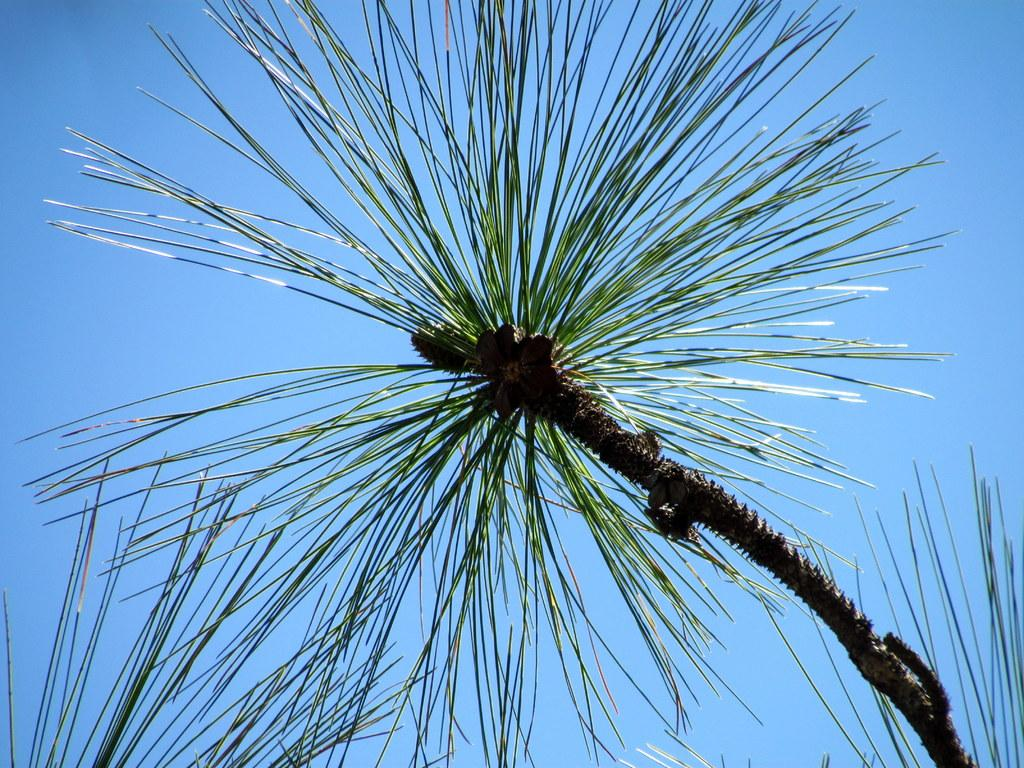What is the main subject in the picture? There is a tree in the picture. What part of the tree is visible in the image? Leaves are visible at the bottom of the tree. What else can be seen in the picture besides the tree? The sky is visible on the right side of the picture. Where is the mailbox located in the picture? There is no mailbox present in the picture; it only features a tree and the sky. What type of ship can be seen sailing in the background of the picture? There is no ship visible in the picture; it only features a tree and the sky. 